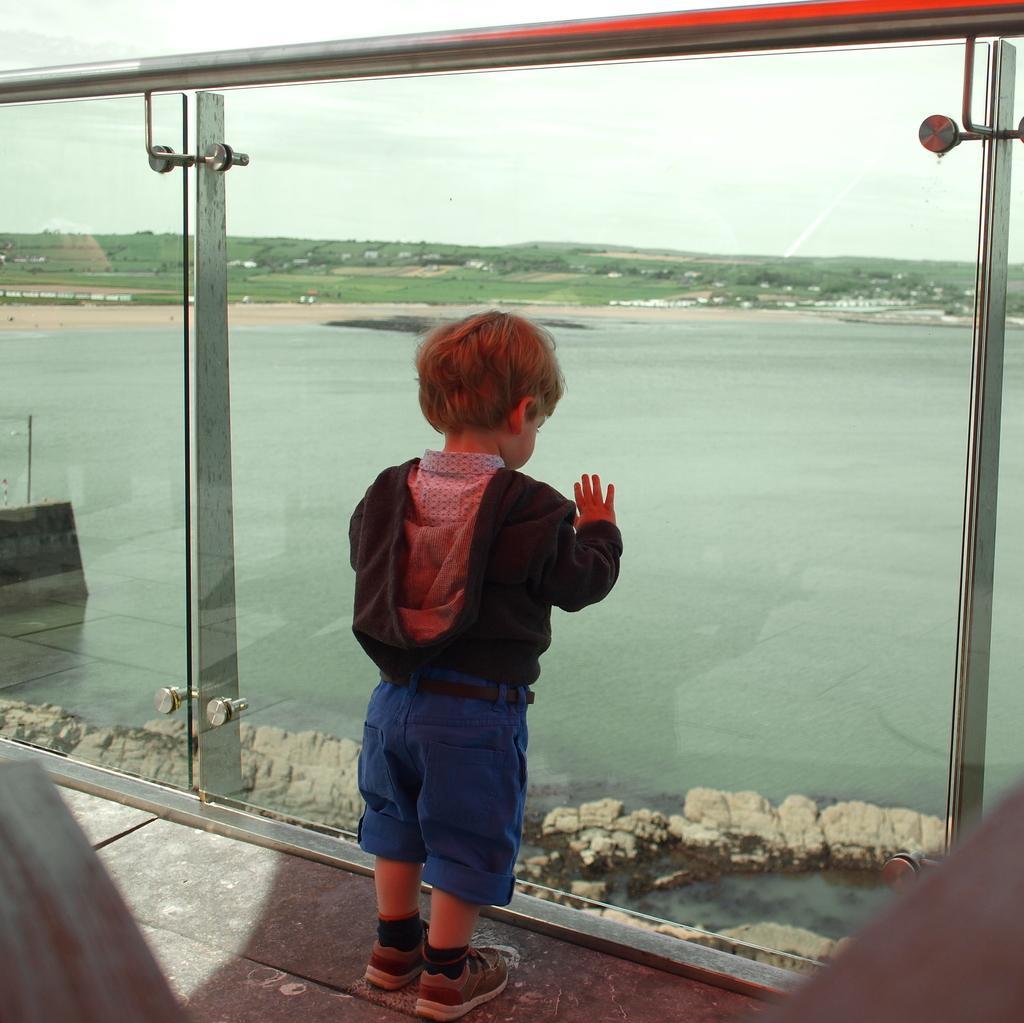Could you give a brief overview of what you see in this image? In the picture we can see a child standing near the glass railing and looking for it, we can see water surface and far away from it, we can see grass surface and behind it we can see the sky. 